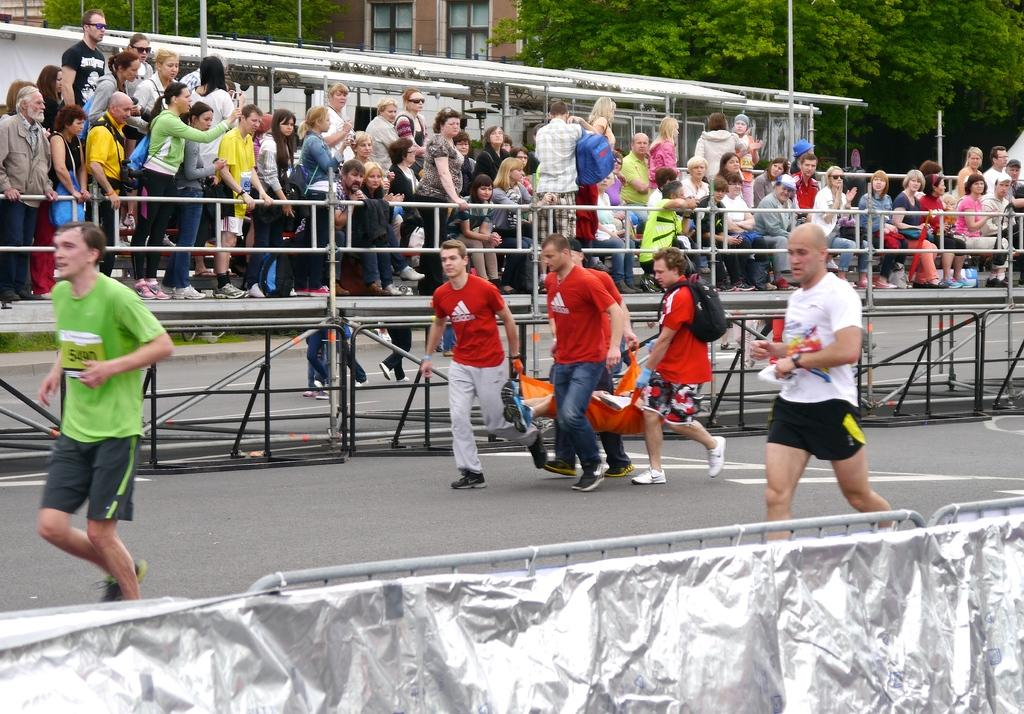What are the people in the image doing? The people in the image are running on the road. What can be seen in the background of the image? There is an audience, buildings, and trees in the background of the image. What type of produce is being harvested by the people in the image? There is no produce or harvesting activity present in the image; the people are running on the road. What kind of structure is being built by the people in the image? There is no structure or construction activity present in the image; the people are running on the road. 